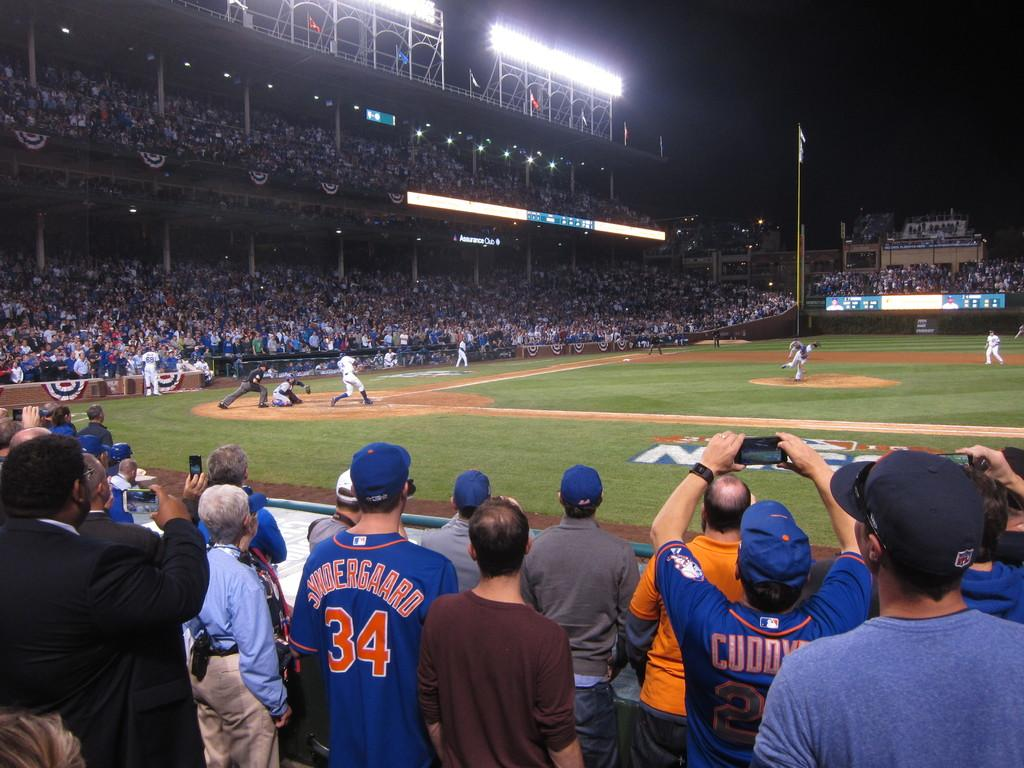<image>
Offer a succinct explanation of the picture presented. Fan in the audience wearing a number 34 jersey watching the game. 